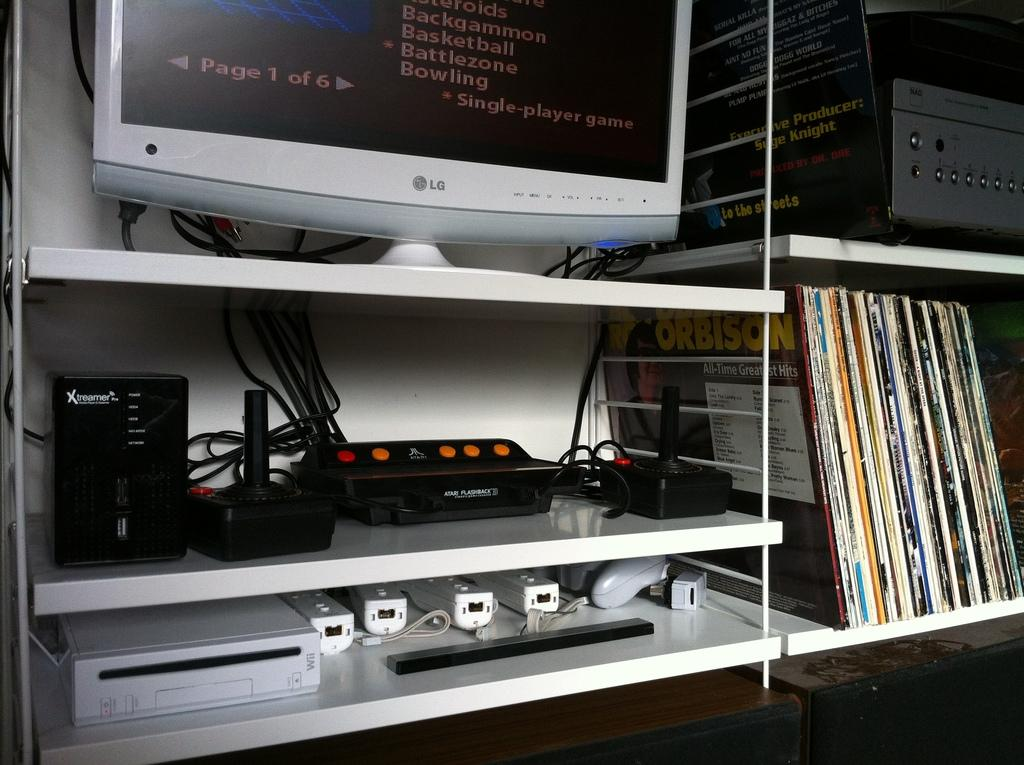<image>
Share a concise interpretation of the image provided. an lg computer screen on a top shelf that says 'page 1 of 6 on the bottom left 